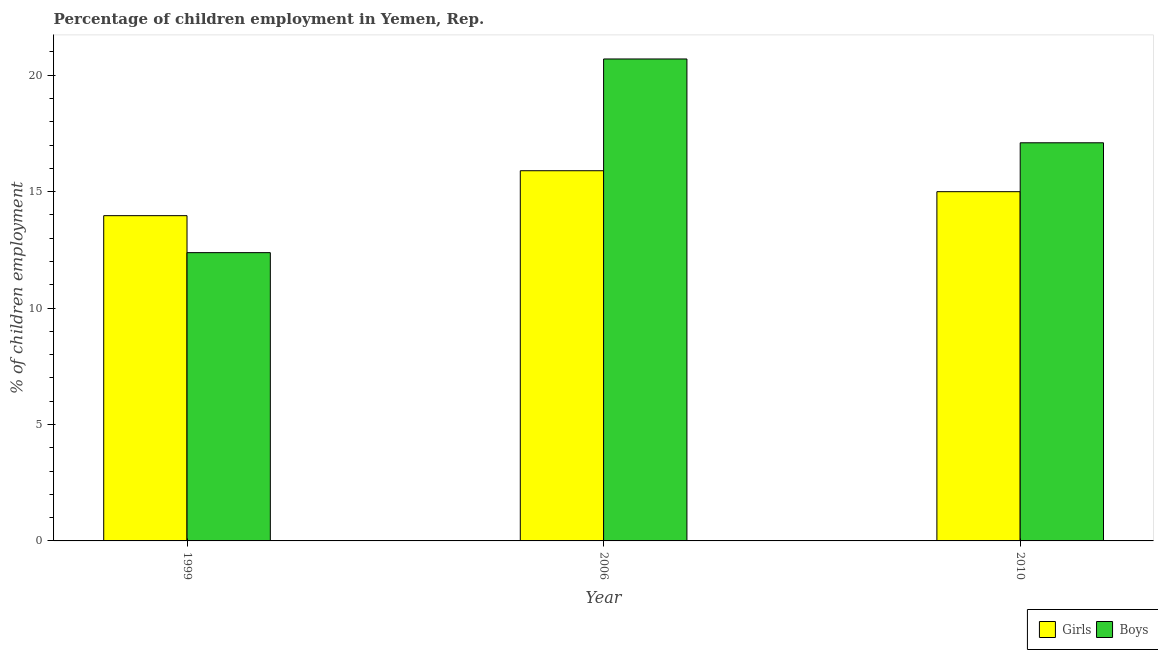How many different coloured bars are there?
Your answer should be very brief. 2. How many groups of bars are there?
Ensure brevity in your answer.  3. Are the number of bars per tick equal to the number of legend labels?
Keep it short and to the point. Yes. Are the number of bars on each tick of the X-axis equal?
Provide a short and direct response. Yes. How many bars are there on the 3rd tick from the right?
Ensure brevity in your answer.  2. Across all years, what is the maximum percentage of employed boys?
Ensure brevity in your answer.  20.7. Across all years, what is the minimum percentage of employed girls?
Your answer should be very brief. 13.97. In which year was the percentage of employed boys maximum?
Your answer should be compact. 2006. In which year was the percentage of employed boys minimum?
Make the answer very short. 1999. What is the total percentage of employed boys in the graph?
Offer a terse response. 50.18. What is the difference between the percentage of employed boys in 1999 and that in 2006?
Keep it short and to the point. -8.32. What is the difference between the percentage of employed girls in 2010 and the percentage of employed boys in 1999?
Offer a terse response. 1.03. What is the average percentage of employed boys per year?
Keep it short and to the point. 16.73. In the year 2006, what is the difference between the percentage of employed boys and percentage of employed girls?
Provide a succinct answer. 0. In how many years, is the percentage of employed boys greater than 18 %?
Provide a succinct answer. 1. What is the ratio of the percentage of employed boys in 2006 to that in 2010?
Provide a succinct answer. 1.21. Is the percentage of employed girls in 1999 less than that in 2006?
Offer a terse response. Yes. Is the difference between the percentage of employed girls in 1999 and 2010 greater than the difference between the percentage of employed boys in 1999 and 2010?
Ensure brevity in your answer.  No. What is the difference between the highest and the second highest percentage of employed boys?
Your response must be concise. 3.6. What is the difference between the highest and the lowest percentage of employed boys?
Give a very brief answer. 8.32. Is the sum of the percentage of employed boys in 1999 and 2010 greater than the maximum percentage of employed girls across all years?
Offer a very short reply. Yes. What does the 2nd bar from the left in 2006 represents?
Your answer should be very brief. Boys. What does the 2nd bar from the right in 1999 represents?
Give a very brief answer. Girls. How many bars are there?
Keep it short and to the point. 6. Are all the bars in the graph horizontal?
Your response must be concise. No. How many years are there in the graph?
Offer a very short reply. 3. Does the graph contain any zero values?
Offer a terse response. No. Where does the legend appear in the graph?
Make the answer very short. Bottom right. What is the title of the graph?
Make the answer very short. Percentage of children employment in Yemen, Rep. What is the label or title of the Y-axis?
Ensure brevity in your answer.  % of children employment. What is the % of children employment in Girls in 1999?
Provide a succinct answer. 13.97. What is the % of children employment of Boys in 1999?
Your answer should be very brief. 12.38. What is the % of children employment in Boys in 2006?
Keep it short and to the point. 20.7. What is the % of children employment in Girls in 2010?
Your answer should be compact. 15. Across all years, what is the maximum % of children employment of Girls?
Provide a short and direct response. 15.9. Across all years, what is the maximum % of children employment of Boys?
Offer a terse response. 20.7. Across all years, what is the minimum % of children employment in Girls?
Offer a terse response. 13.97. Across all years, what is the minimum % of children employment of Boys?
Your answer should be compact. 12.38. What is the total % of children employment in Girls in the graph?
Provide a short and direct response. 44.87. What is the total % of children employment in Boys in the graph?
Your response must be concise. 50.18. What is the difference between the % of children employment of Girls in 1999 and that in 2006?
Provide a short and direct response. -1.93. What is the difference between the % of children employment in Boys in 1999 and that in 2006?
Keep it short and to the point. -8.32. What is the difference between the % of children employment in Girls in 1999 and that in 2010?
Offer a very short reply. -1.03. What is the difference between the % of children employment of Boys in 1999 and that in 2010?
Give a very brief answer. -4.72. What is the difference between the % of children employment in Boys in 2006 and that in 2010?
Your answer should be very brief. 3.6. What is the difference between the % of children employment of Girls in 1999 and the % of children employment of Boys in 2006?
Offer a very short reply. -6.73. What is the difference between the % of children employment of Girls in 1999 and the % of children employment of Boys in 2010?
Keep it short and to the point. -3.13. What is the difference between the % of children employment in Girls in 2006 and the % of children employment in Boys in 2010?
Give a very brief answer. -1.2. What is the average % of children employment of Girls per year?
Your response must be concise. 14.96. What is the average % of children employment in Boys per year?
Keep it short and to the point. 16.73. In the year 1999, what is the difference between the % of children employment in Girls and % of children employment in Boys?
Make the answer very short. 1.59. In the year 2006, what is the difference between the % of children employment of Girls and % of children employment of Boys?
Make the answer very short. -4.8. What is the ratio of the % of children employment of Girls in 1999 to that in 2006?
Your response must be concise. 0.88. What is the ratio of the % of children employment in Boys in 1999 to that in 2006?
Your answer should be compact. 0.6. What is the ratio of the % of children employment of Girls in 1999 to that in 2010?
Ensure brevity in your answer.  0.93. What is the ratio of the % of children employment of Boys in 1999 to that in 2010?
Ensure brevity in your answer.  0.72. What is the ratio of the % of children employment in Girls in 2006 to that in 2010?
Your answer should be compact. 1.06. What is the ratio of the % of children employment in Boys in 2006 to that in 2010?
Your response must be concise. 1.21. What is the difference between the highest and the second highest % of children employment of Girls?
Provide a short and direct response. 0.9. What is the difference between the highest and the lowest % of children employment of Girls?
Offer a terse response. 1.93. What is the difference between the highest and the lowest % of children employment in Boys?
Offer a very short reply. 8.32. 